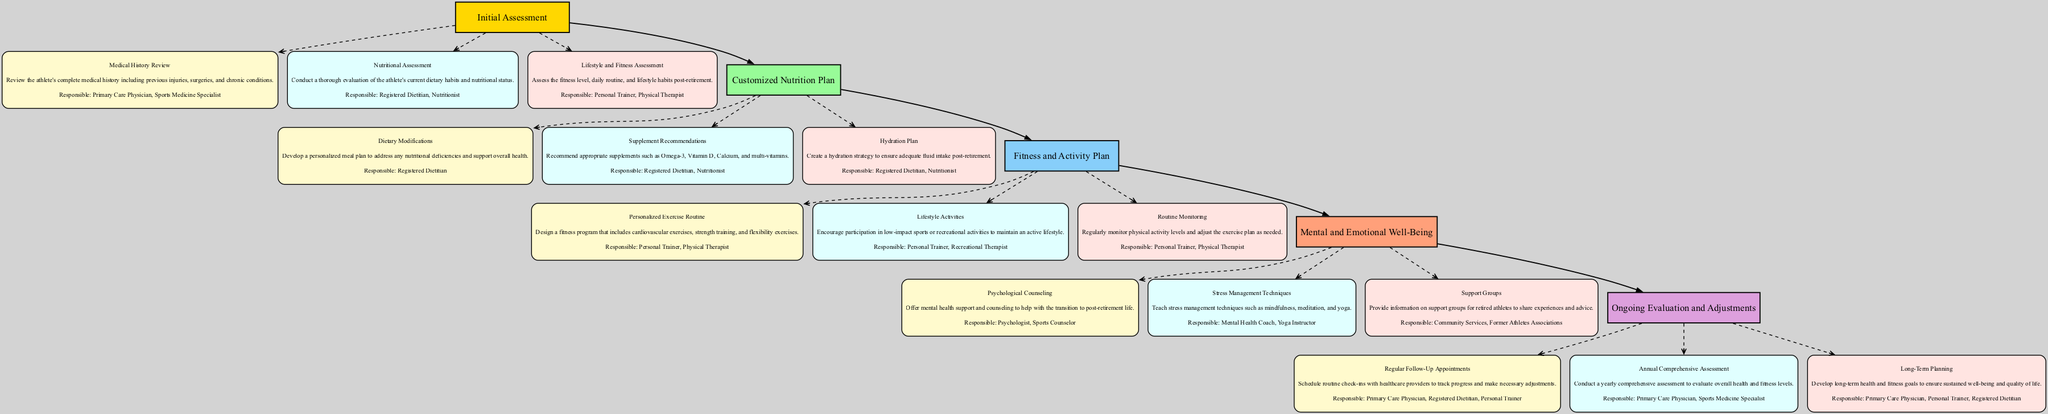What is the first stage in the Clinical Pathway? The first stage listed in the diagram is "Initial Assessment". It is categorically placed at the top of the pathway, indicating it is the starting point before proceeding to subsequent stages.
Answer: Initial Assessment How many components are there in the "Customized Nutrition Plan" stage? In the "Customized Nutrition Plan", there are three components: Dietary Modifications, Supplement Recommendations, and Hydration Plan. This can be counted directly from the diagram representing that stage.
Answer: 3 Who is responsible for the "Psychological Counseling" component? The responsible parties for "Psychological Counseling" are identified as "Psychologist" and "Sports Counselor" in the diagram. Each component explicitly lists its associated responsible parties, making this information directly accessible.
Answer: Psychologist, Sports Counselor What type of assessment is conducted in the second stage of the pathway? The second stage is "Customized Nutrition Plan", and it focuses primarily on dietary assessments, as indicated by the components that include Dietary Modifications, Supplement Recommendations, and Hydration Plan.
Answer: Nutritional assessments Which parties are involved in the "Routine Monitoring"? The responsible parties for "Routine Monitoring" are clearly listed in the diagram as "Personal Trainer" and "Physical Therapist". This information can be found within the description of that specific component in the diagram.
Answer: Personal Trainer, Physical Therapist What is the last component listed in the "Ongoing Evaluation and Adjustments" stage? The last component in this stage is "Long-Term Planning". Components are sequentially arranged in the order they are listed in the Clinical Pathway.
Answer: Long-Term Planning How many stages are there in total? There are five stages as represented in the diagram. Counting each stage from top to bottom provides the total number of stages in the Clinical Pathway.
Answer: 5 Name one technique taught in the "Mental and Emotional Well-Being" stage. One technique offered in the "Mental and Emotional Well-Being" stage is "Stress Management Techniques", which focuses on methods for managing stress post-retirement through mindfulness and other practices. This component is explicitly mentioned within that stage of the pathway.
Answer: Stress Management Techniques What connects the "Personalized Exercise Routine" to the "Lifestyle Activities"? The "Personalized Exercise Routine" and "Lifestyle Activities" are both components under the "Fitness and Activity Plan" stage, making them sequentially linked within that specific stage of the Clinical Pathway.
Answer: The Fitness and Activity Plan stage 